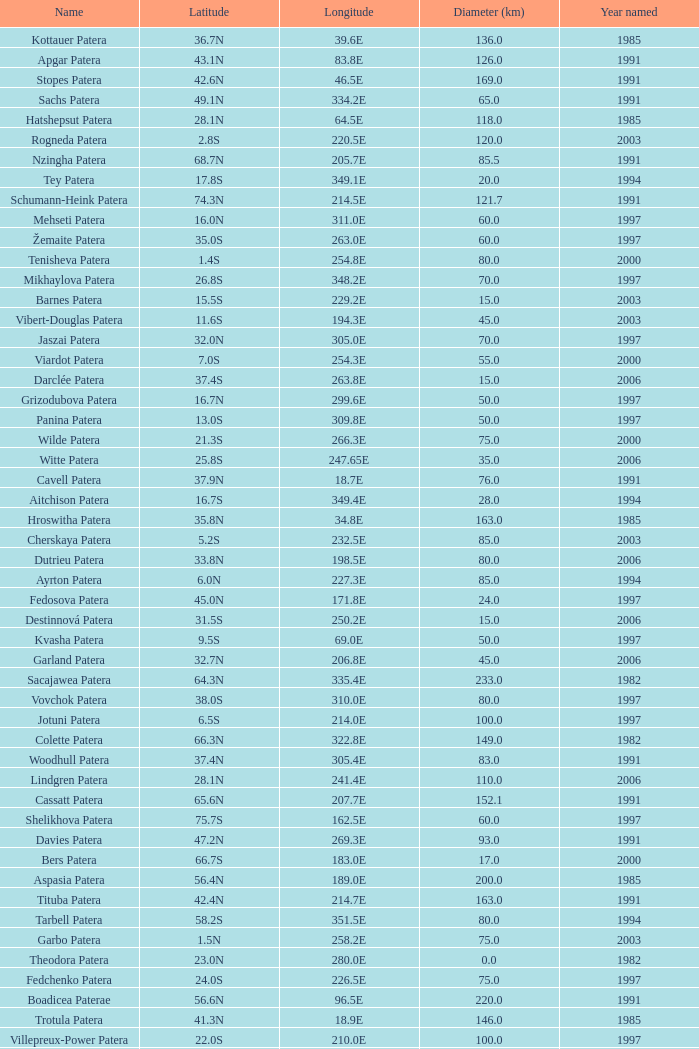What is Longitude, when Name is Raskova Paterae? 222.8E. 